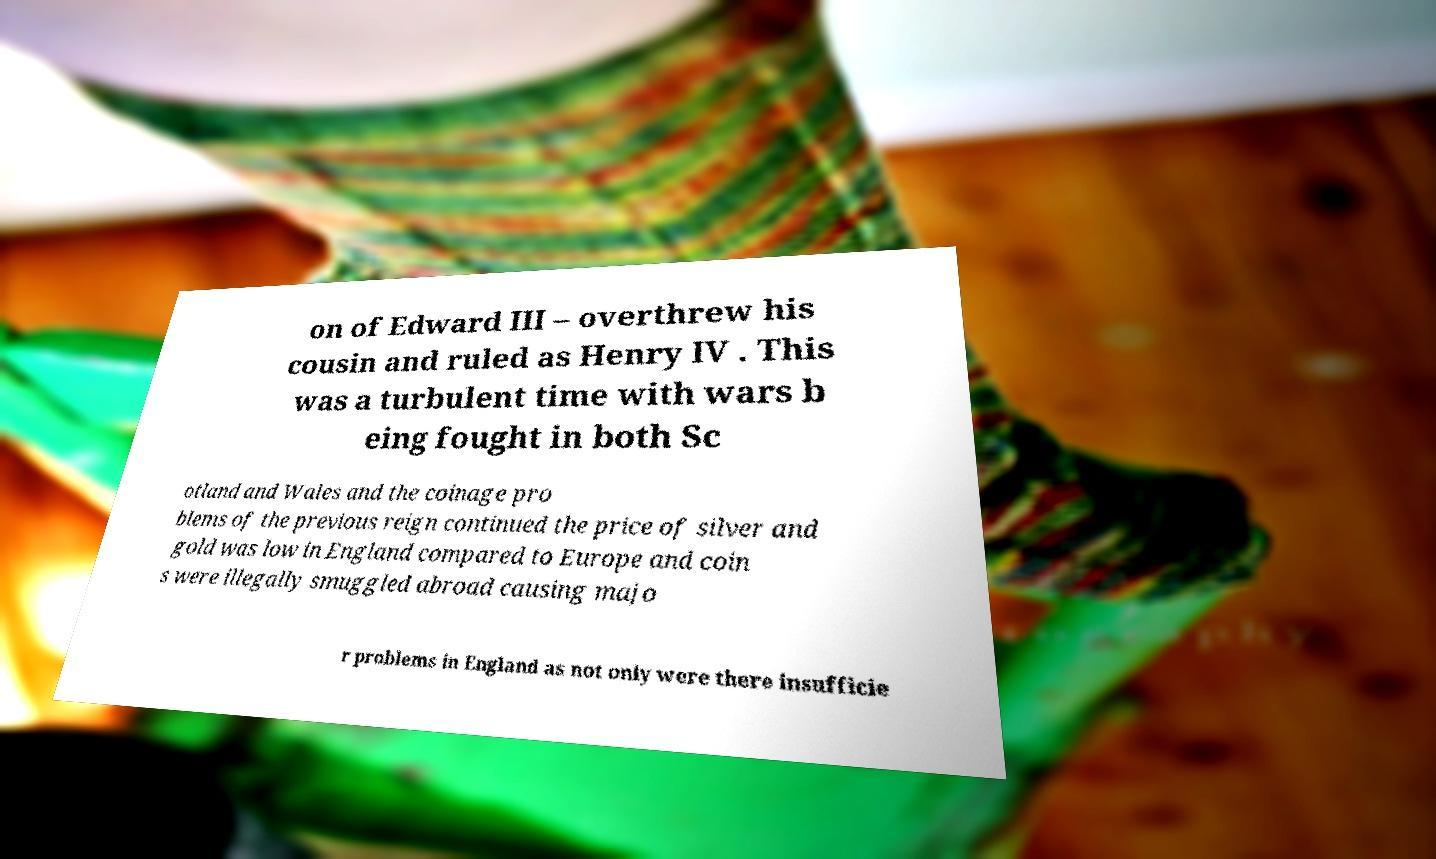Could you assist in decoding the text presented in this image and type it out clearly? on of Edward III – overthrew his cousin and ruled as Henry IV . This was a turbulent time with wars b eing fought in both Sc otland and Wales and the coinage pro blems of the previous reign continued the price of silver and gold was low in England compared to Europe and coin s were illegally smuggled abroad causing majo r problems in England as not only were there insufficie 